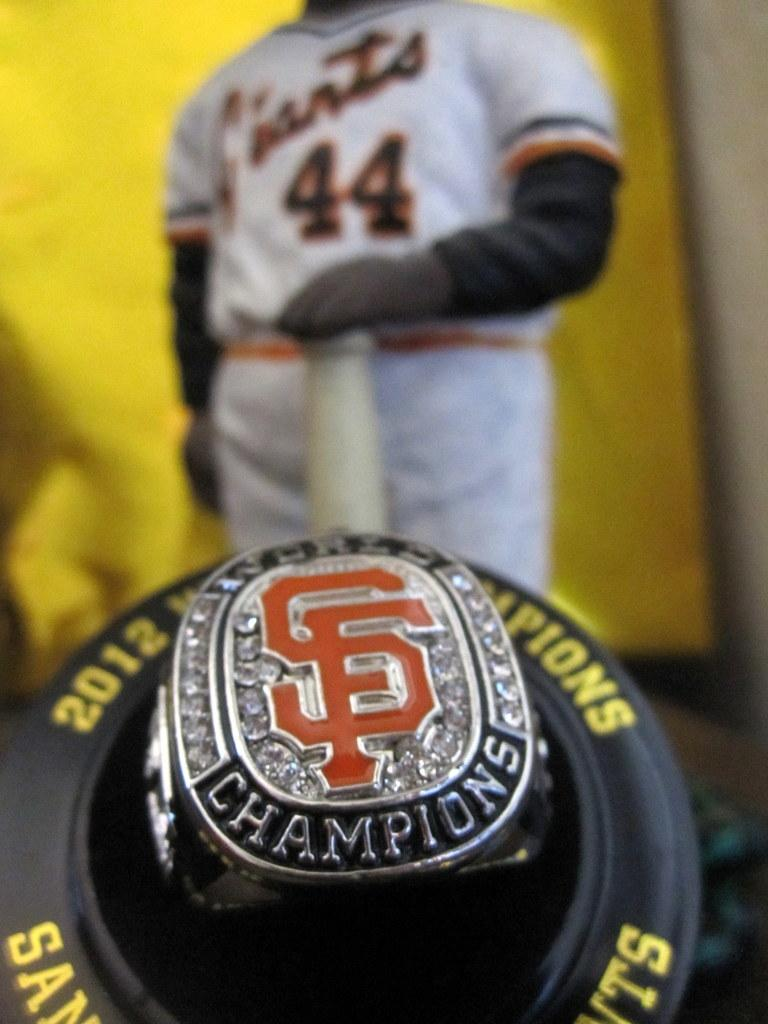<image>
Summarize the visual content of the image. The figure standing behind  the champions ring is wearing a Giants 44 shirt. 